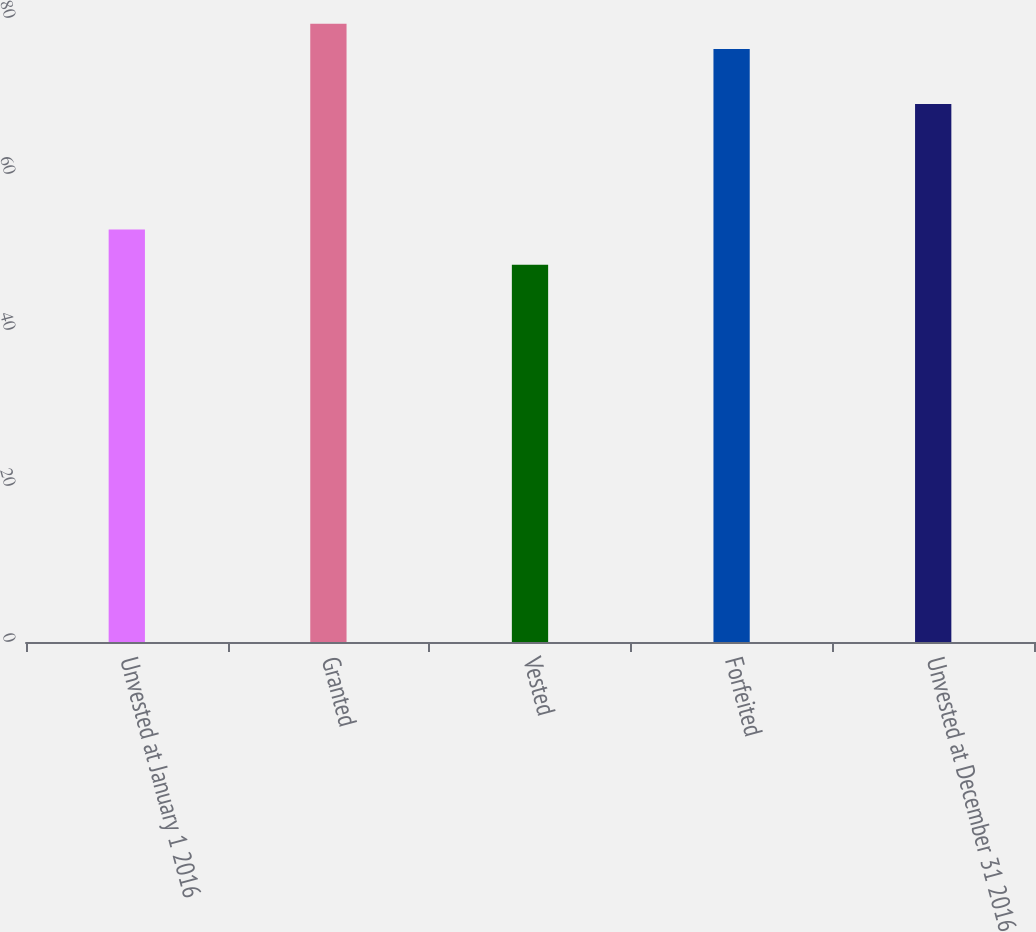<chart> <loc_0><loc_0><loc_500><loc_500><bar_chart><fcel>Unvested at January 1 2016<fcel>Granted<fcel>Vested<fcel>Forfeited<fcel>Unvested at December 31 2016<nl><fcel>52.9<fcel>79.27<fcel>48.38<fcel>76.01<fcel>68.98<nl></chart> 